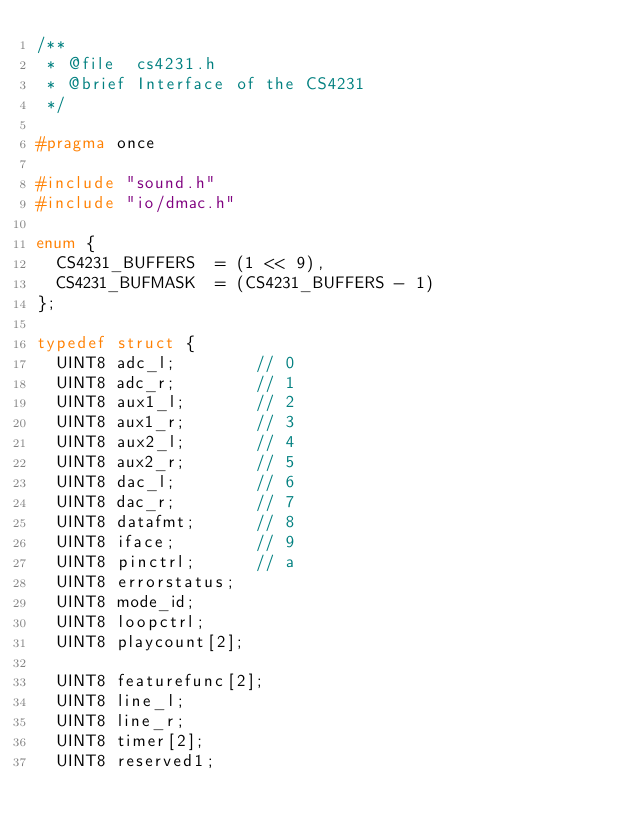Convert code to text. <code><loc_0><loc_0><loc_500><loc_500><_C_>/**
 * @file	cs4231.h
 * @brief	Interface of the CS4231
 */

#pragma once

#include "sound.h"
#include "io/dmac.h"

enum {
	CS4231_BUFFERS	= (1 << 9),
	CS4231_BUFMASK	= (CS4231_BUFFERS - 1)
};

typedef struct {
	UINT8	adc_l;				// 0
	UINT8	adc_r;				// 1
	UINT8	aux1_l;				// 2
	UINT8	aux1_r;				// 3
	UINT8	aux2_l;				// 4
	UINT8	aux2_r;				// 5
	UINT8	dac_l;				// 6
	UINT8	dac_r;				// 7
	UINT8	datafmt;			// 8
	UINT8	iface;				// 9
	UINT8	pinctrl;			// a
	UINT8	errorstatus;
	UINT8	mode_id;
	UINT8	loopctrl;
	UINT8	playcount[2];

	UINT8	featurefunc[2];
	UINT8	line_l;
	UINT8	line_r;
	UINT8	timer[2];
	UINT8	reserved1;</code> 